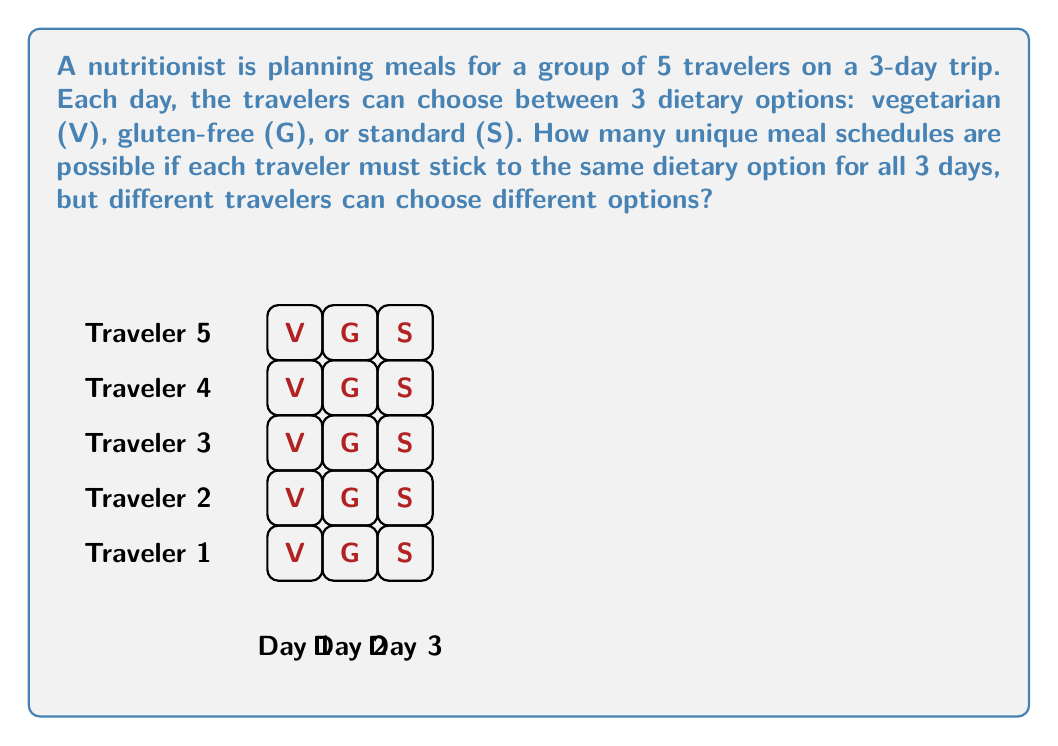Can you answer this question? Let's approach this step-by-step:

1) First, we need to understand what the question is asking. Each traveler must choose one dietary option (V, G, or S) and stick to it for all 3 days.

2) This means that for each traveler, there are 3 choices.

3) We need to make this choice for each of the 5 travelers independently.

4) This scenario is a perfect example of the multiplication principle in combinatorics. When we have a series of independent choices, we multiply the number of options for each choice.

5) In this case, we have:
   - 3 choices for the first traveler
   - 3 choices for the second traveler
   - 3 choices for the third traveler
   - 3 choices for the fourth traveler
   - 3 choices for the fifth traveler

6) Therefore, the total number of unique meal schedules is:

   $$3 \times 3 \times 3 \times 3 \times 3 = 3^5$$

7) We can calculate this:

   $$3^5 = 3 \times 3 \times 3 \times 3 \times 3 = 243$$

Thus, there are 243 unique meal schedules possible.
Answer: $3^5 = 243$ 